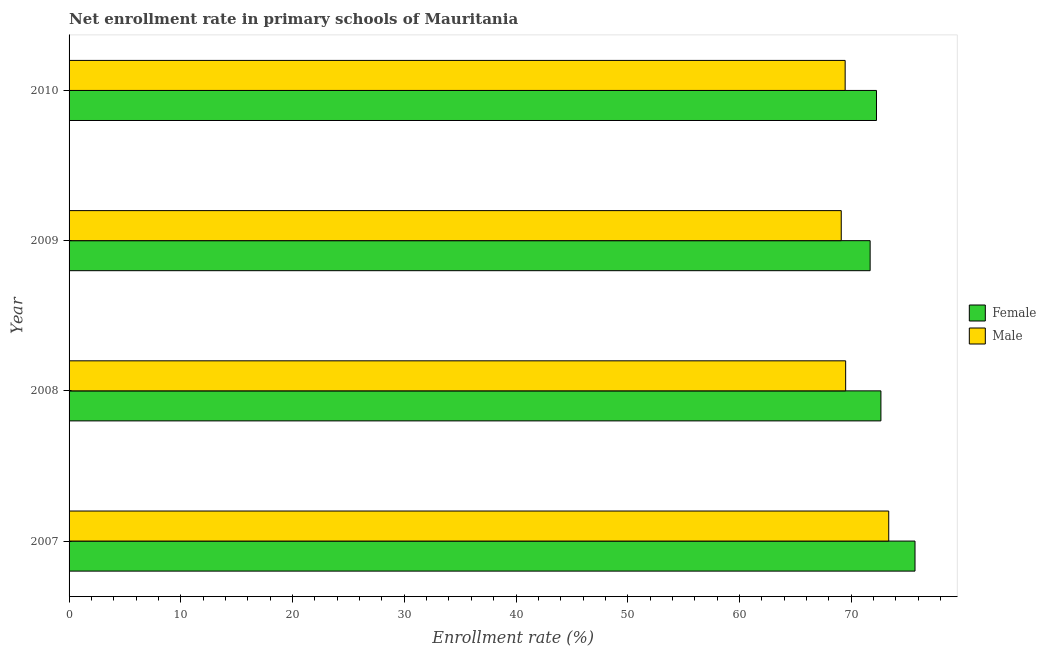How many different coloured bars are there?
Your answer should be very brief. 2. How many groups of bars are there?
Offer a very short reply. 4. How many bars are there on the 3rd tick from the bottom?
Your response must be concise. 2. What is the label of the 1st group of bars from the top?
Give a very brief answer. 2010. What is the enrollment rate of female students in 2009?
Ensure brevity in your answer.  71.69. Across all years, what is the maximum enrollment rate of male students?
Provide a succinct answer. 73.36. Across all years, what is the minimum enrollment rate of female students?
Provide a short and direct response. 71.69. What is the total enrollment rate of male students in the graph?
Make the answer very short. 281.42. What is the difference between the enrollment rate of female students in 2007 and that in 2009?
Make the answer very short. 4.02. What is the difference between the enrollment rate of male students in 2009 and the enrollment rate of female students in 2007?
Provide a succinct answer. -6.6. What is the average enrollment rate of female students per year?
Give a very brief answer. 73.08. In the year 2010, what is the difference between the enrollment rate of male students and enrollment rate of female students?
Provide a short and direct response. -2.8. In how many years, is the enrollment rate of male students greater than 20 %?
Provide a succinct answer. 4. What is the ratio of the enrollment rate of male students in 2007 to that in 2008?
Provide a succinct answer. 1.05. What is the difference between the highest and the second highest enrollment rate of female students?
Your answer should be compact. 3.05. What is the difference between the highest and the lowest enrollment rate of female students?
Ensure brevity in your answer.  4.02. Is the sum of the enrollment rate of female students in 2007 and 2008 greater than the maximum enrollment rate of male students across all years?
Give a very brief answer. Yes. What does the 1st bar from the top in 2010 represents?
Offer a terse response. Male. How many bars are there?
Offer a terse response. 8. Are all the bars in the graph horizontal?
Provide a short and direct response. Yes. Does the graph contain grids?
Offer a terse response. No. Where does the legend appear in the graph?
Provide a succinct answer. Center right. How are the legend labels stacked?
Offer a terse response. Vertical. What is the title of the graph?
Your answer should be very brief. Net enrollment rate in primary schools of Mauritania. Does "Electricity and heat production" appear as one of the legend labels in the graph?
Offer a very short reply. No. What is the label or title of the X-axis?
Your response must be concise. Enrollment rate (%). What is the label or title of the Y-axis?
Keep it short and to the point. Year. What is the Enrollment rate (%) of Female in 2007?
Your answer should be compact. 75.71. What is the Enrollment rate (%) of Male in 2007?
Give a very brief answer. 73.36. What is the Enrollment rate (%) in Female in 2008?
Offer a terse response. 72.66. What is the Enrollment rate (%) of Male in 2008?
Keep it short and to the point. 69.5. What is the Enrollment rate (%) of Female in 2009?
Your response must be concise. 71.69. What is the Enrollment rate (%) of Male in 2009?
Ensure brevity in your answer.  69.11. What is the Enrollment rate (%) in Female in 2010?
Ensure brevity in your answer.  72.26. What is the Enrollment rate (%) in Male in 2010?
Your response must be concise. 69.46. Across all years, what is the maximum Enrollment rate (%) of Female?
Keep it short and to the point. 75.71. Across all years, what is the maximum Enrollment rate (%) in Male?
Give a very brief answer. 73.36. Across all years, what is the minimum Enrollment rate (%) of Female?
Your answer should be compact. 71.69. Across all years, what is the minimum Enrollment rate (%) of Male?
Keep it short and to the point. 69.11. What is the total Enrollment rate (%) of Female in the graph?
Give a very brief answer. 292.31. What is the total Enrollment rate (%) in Male in the graph?
Provide a succinct answer. 281.42. What is the difference between the Enrollment rate (%) in Female in 2007 and that in 2008?
Keep it short and to the point. 3.05. What is the difference between the Enrollment rate (%) in Male in 2007 and that in 2008?
Provide a short and direct response. 3.86. What is the difference between the Enrollment rate (%) in Female in 2007 and that in 2009?
Provide a succinct answer. 4.02. What is the difference between the Enrollment rate (%) in Male in 2007 and that in 2009?
Your answer should be very brief. 4.25. What is the difference between the Enrollment rate (%) in Female in 2007 and that in 2010?
Make the answer very short. 3.45. What is the difference between the Enrollment rate (%) of Male in 2007 and that in 2010?
Provide a succinct answer. 3.9. What is the difference between the Enrollment rate (%) in Female in 2008 and that in 2009?
Offer a very short reply. 0.96. What is the difference between the Enrollment rate (%) of Male in 2008 and that in 2009?
Give a very brief answer. 0.39. What is the difference between the Enrollment rate (%) of Female in 2008 and that in 2010?
Offer a very short reply. 0.4. What is the difference between the Enrollment rate (%) of Male in 2008 and that in 2010?
Provide a succinct answer. 0.04. What is the difference between the Enrollment rate (%) in Female in 2009 and that in 2010?
Provide a succinct answer. -0.57. What is the difference between the Enrollment rate (%) in Male in 2009 and that in 2010?
Your answer should be compact. -0.35. What is the difference between the Enrollment rate (%) in Female in 2007 and the Enrollment rate (%) in Male in 2008?
Provide a short and direct response. 6.21. What is the difference between the Enrollment rate (%) in Female in 2007 and the Enrollment rate (%) in Male in 2009?
Ensure brevity in your answer.  6.6. What is the difference between the Enrollment rate (%) of Female in 2007 and the Enrollment rate (%) of Male in 2010?
Your answer should be compact. 6.25. What is the difference between the Enrollment rate (%) of Female in 2008 and the Enrollment rate (%) of Male in 2009?
Your answer should be very brief. 3.55. What is the difference between the Enrollment rate (%) in Female in 2008 and the Enrollment rate (%) in Male in 2010?
Your answer should be very brief. 3.2. What is the difference between the Enrollment rate (%) in Female in 2009 and the Enrollment rate (%) in Male in 2010?
Offer a very short reply. 2.24. What is the average Enrollment rate (%) of Female per year?
Make the answer very short. 73.08. What is the average Enrollment rate (%) in Male per year?
Provide a succinct answer. 70.35. In the year 2007, what is the difference between the Enrollment rate (%) in Female and Enrollment rate (%) in Male?
Your answer should be very brief. 2.35. In the year 2008, what is the difference between the Enrollment rate (%) in Female and Enrollment rate (%) in Male?
Provide a short and direct response. 3.16. In the year 2009, what is the difference between the Enrollment rate (%) in Female and Enrollment rate (%) in Male?
Give a very brief answer. 2.58. In the year 2010, what is the difference between the Enrollment rate (%) in Female and Enrollment rate (%) in Male?
Ensure brevity in your answer.  2.8. What is the ratio of the Enrollment rate (%) in Female in 2007 to that in 2008?
Provide a succinct answer. 1.04. What is the ratio of the Enrollment rate (%) of Male in 2007 to that in 2008?
Make the answer very short. 1.06. What is the ratio of the Enrollment rate (%) in Female in 2007 to that in 2009?
Offer a very short reply. 1.06. What is the ratio of the Enrollment rate (%) in Male in 2007 to that in 2009?
Ensure brevity in your answer.  1.06. What is the ratio of the Enrollment rate (%) of Female in 2007 to that in 2010?
Ensure brevity in your answer.  1.05. What is the ratio of the Enrollment rate (%) in Male in 2007 to that in 2010?
Make the answer very short. 1.06. What is the ratio of the Enrollment rate (%) in Female in 2008 to that in 2009?
Provide a succinct answer. 1.01. What is the ratio of the Enrollment rate (%) of Female in 2008 to that in 2010?
Your answer should be very brief. 1.01. What is the ratio of the Enrollment rate (%) of Female in 2009 to that in 2010?
Keep it short and to the point. 0.99. What is the difference between the highest and the second highest Enrollment rate (%) of Female?
Your answer should be compact. 3.05. What is the difference between the highest and the second highest Enrollment rate (%) in Male?
Offer a very short reply. 3.86. What is the difference between the highest and the lowest Enrollment rate (%) in Female?
Offer a terse response. 4.02. What is the difference between the highest and the lowest Enrollment rate (%) of Male?
Your answer should be very brief. 4.25. 